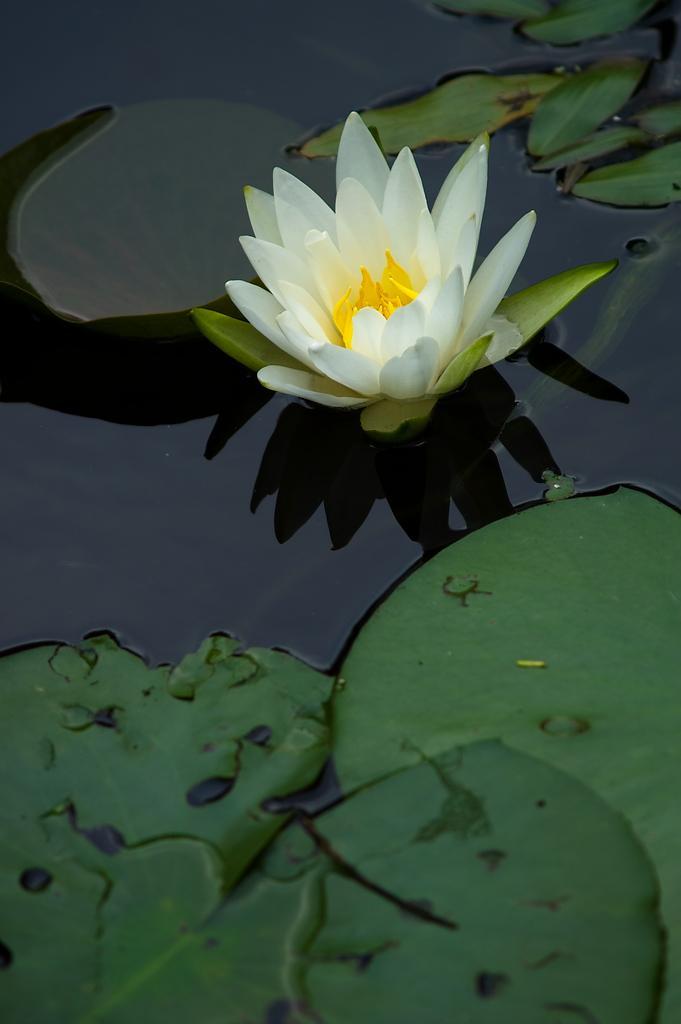Please provide a concise description of this image. In this image I can see a flower in the water. The flower is in white and yellow color and I can see leaves in green color. 